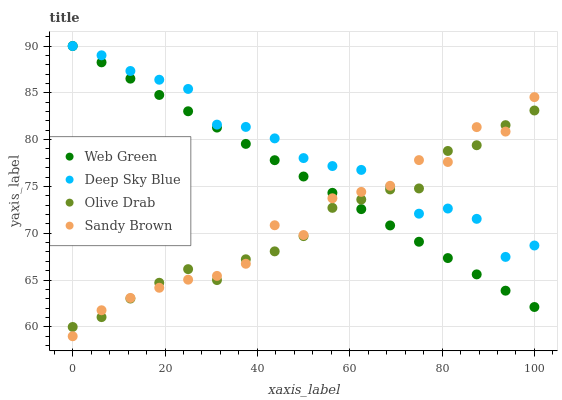Does Olive Drab have the minimum area under the curve?
Answer yes or no. Yes. Does Deep Sky Blue have the maximum area under the curve?
Answer yes or no. Yes. Does Sandy Brown have the minimum area under the curve?
Answer yes or no. No. Does Sandy Brown have the maximum area under the curve?
Answer yes or no. No. Is Web Green the smoothest?
Answer yes or no. Yes. Is Sandy Brown the roughest?
Answer yes or no. Yes. Is Deep Sky Blue the smoothest?
Answer yes or no. No. Is Deep Sky Blue the roughest?
Answer yes or no. No. Does Sandy Brown have the lowest value?
Answer yes or no. Yes. Does Deep Sky Blue have the lowest value?
Answer yes or no. No. Does Web Green have the highest value?
Answer yes or no. Yes. Does Sandy Brown have the highest value?
Answer yes or no. No. Does Deep Sky Blue intersect Olive Drab?
Answer yes or no. Yes. Is Deep Sky Blue less than Olive Drab?
Answer yes or no. No. Is Deep Sky Blue greater than Olive Drab?
Answer yes or no. No. 